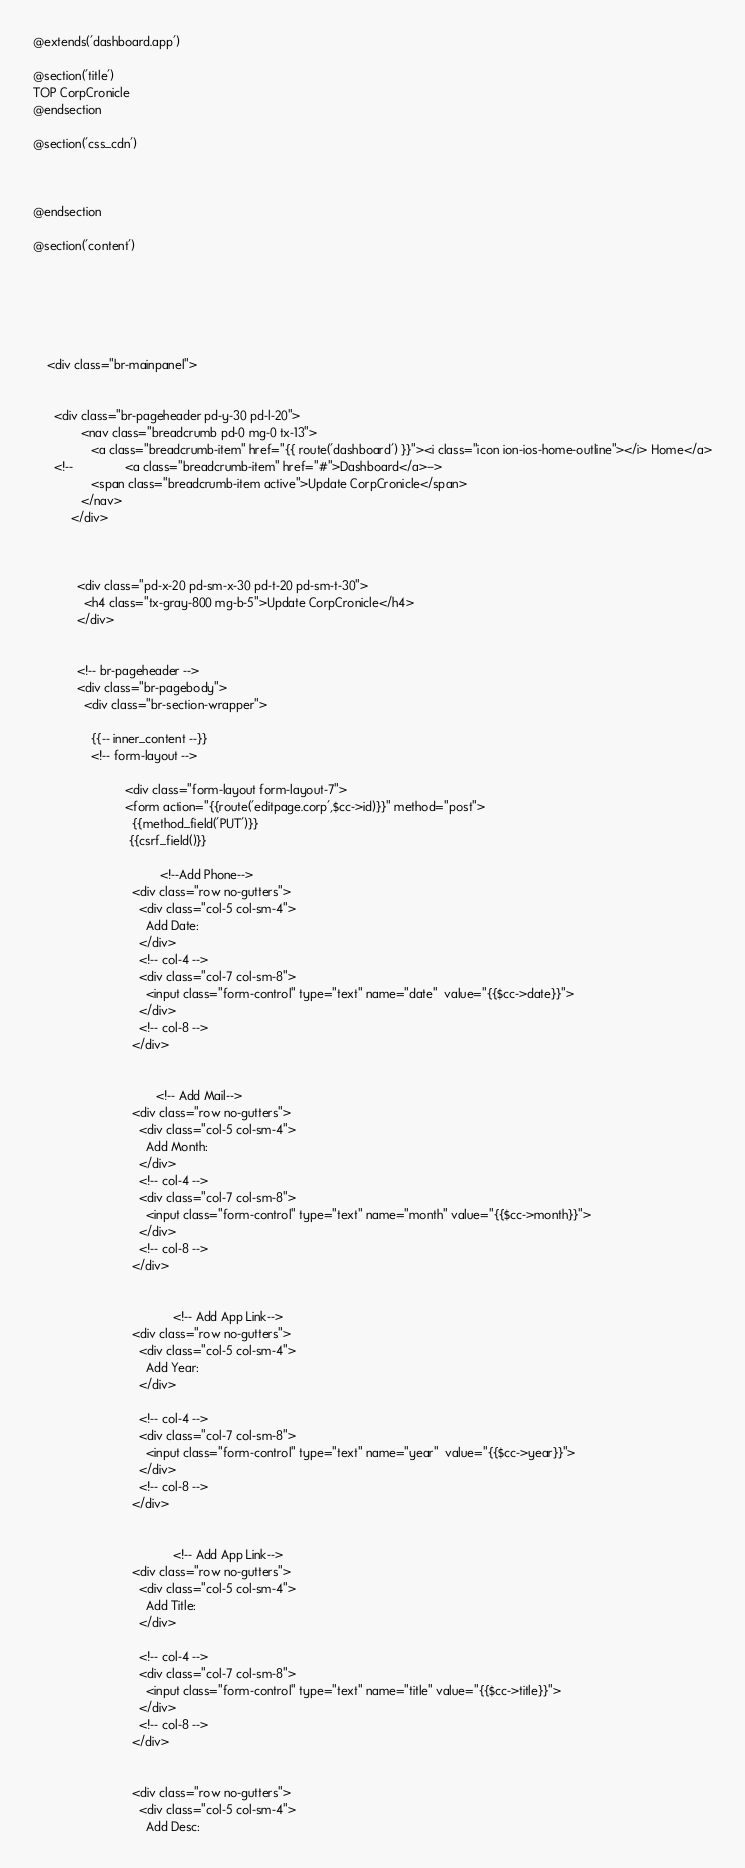Convert code to text. <code><loc_0><loc_0><loc_500><loc_500><_PHP_>@extends('dashboard.app')

@section('title')
TOP CorpCronicle
@endsection

@section('css_cdn')



@endsection

@section('content')






    <div class="br-mainpanel">


      <div class="br-pageheader pd-y-30 pd-l-20">
              <nav class="breadcrumb pd-0 mg-0 tx-13">
                 <a class="breadcrumb-item" href="{{ route('dashboard') }}"><i class="icon ion-ios-home-outline"></i> Home</a>
      <!--               <a class="breadcrumb-item" href="#">Dashboard</a>-->
                 <span class="breadcrumb-item active">Update CorpCronicle</span>
              </nav>
           </div>



             <div class="pd-x-20 pd-sm-x-30 pd-t-20 pd-sm-t-30">
               <h4 class="tx-gray-800 mg-b-5">Update CorpCronicle</h4>
             </div>


             <!-- br-pageheader -->
             <div class="br-pagebody">
               <div class="br-section-wrapper">

                 {{-- inner_content --}}
                 <!-- form-layout -->

                           <div class="form-layout form-layout-7">
                           <form action="{{route('editpage.corp',$cc->id)}}" method="post">
                             {{method_field('PUT')}}
       						{{csrf_field()}}

                                     <!--Add Phone-->
                             <div class="row no-gutters">
                               <div class="col-5 col-sm-4">
                                 Add Date:
                               </div>
                               <!-- col-4 -->
                               <div class="col-7 col-sm-8">
                                 <input class="form-control" type="text" name="date"  value="{{$cc->date}}">
                               </div>
                               <!-- col-8 -->
                             </div>


                                    <!-- Add Mail-->
                             <div class="row no-gutters">
                               <div class="col-5 col-sm-4">
                                 Add Month:
                               </div>
                               <!-- col-4 -->
                               <div class="col-7 col-sm-8">
                                 <input class="form-control" type="text" name="month" value="{{$cc->month}}">
                               </div>
                               <!-- col-8 -->
                             </div>


                                         <!-- Add App Link-->
                             <div class="row no-gutters">
                               <div class="col-5 col-sm-4">
                                 Add Year:
                               </div>

                               <!-- col-4 -->
                               <div class="col-7 col-sm-8">
                                 <input class="form-control" type="text" name="year"  value="{{$cc->year}}">
                               </div>
                               <!-- col-8 -->
                             </div>


                                         <!-- Add App Link-->
                             <div class="row no-gutters">
                               <div class="col-5 col-sm-4">
                                 Add Title:
                               </div>

                               <!-- col-4 -->
                               <div class="col-7 col-sm-8">
                                 <input class="form-control" type="text" name="title" value="{{$cc->title}}">
                               </div>
                               <!-- col-8 -->
                             </div>


                             <div class="row no-gutters">
                               <div class="col-5 col-sm-4">
                                 Add Desc:</code> 